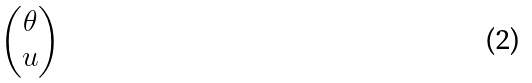Convert formula to latex. <formula><loc_0><loc_0><loc_500><loc_500>\begin{pmatrix} \theta \\ u \end{pmatrix}</formula> 